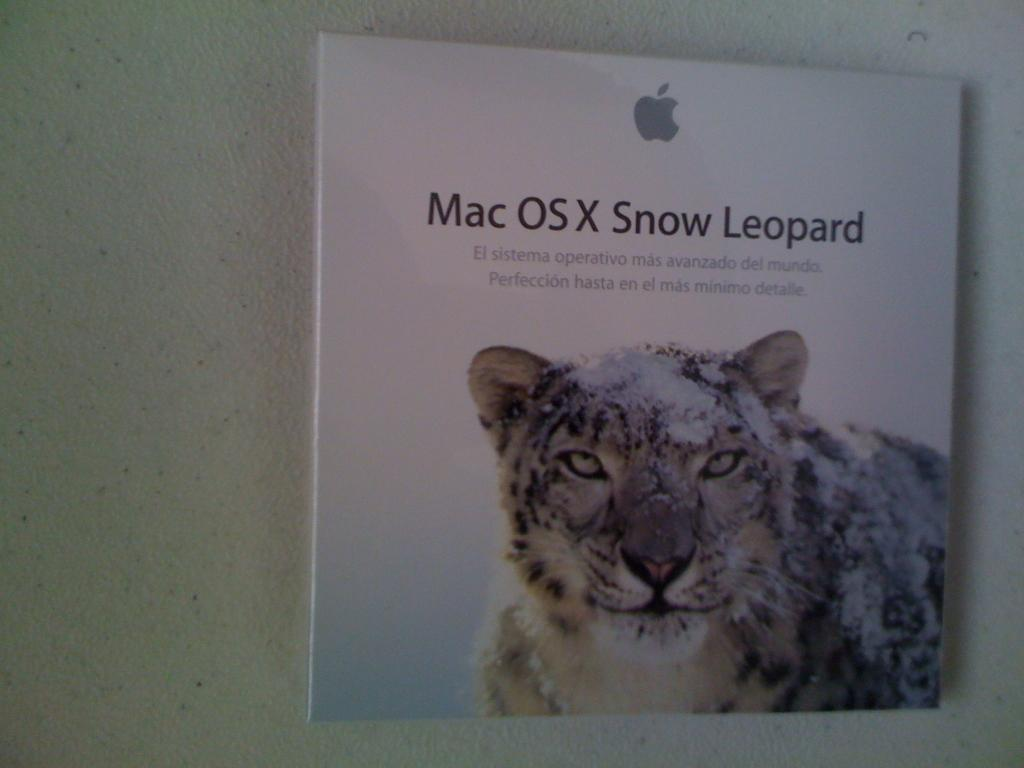What can be seen in the image? There is an object in the image. What is unique about the object? The object has text printed on it. What else is featured on the object? The object has an animal printed on it. What else is visible in the image? There is a wall in the image. How many boats are sailing in the image? There are no boats present in the image. What type of twist can be seen in the image? There is no twist visible in the image. 